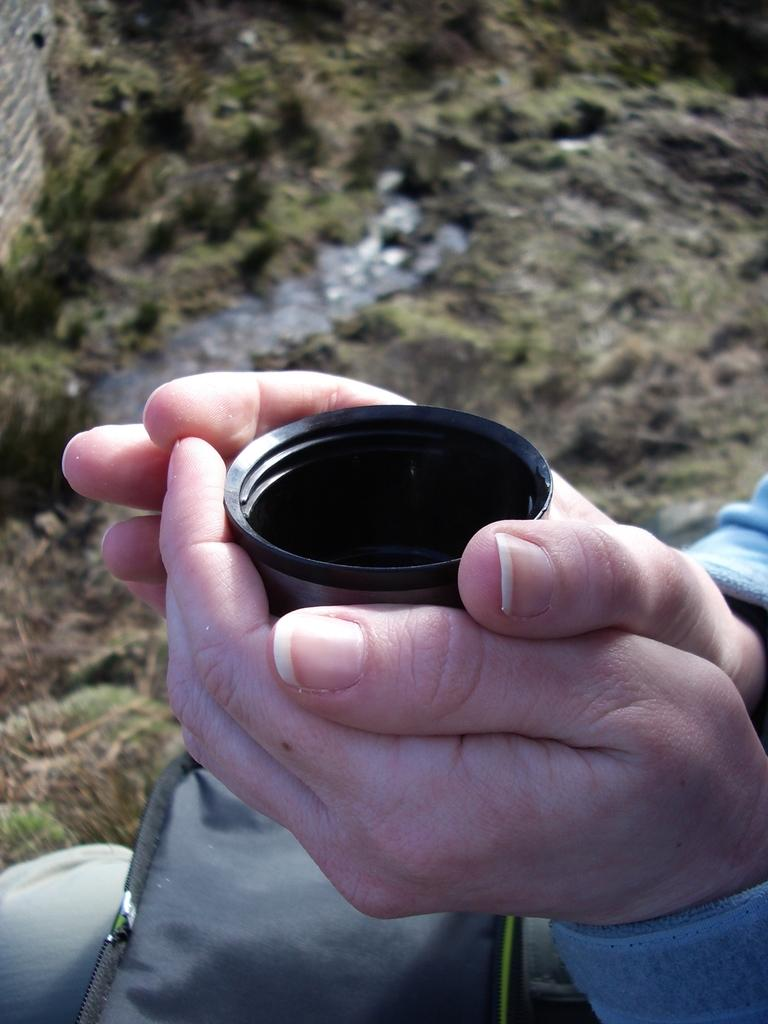What is present in the image? There is a person in the image. What is the person doing in the image? The person is holding an object. What type of degree is the person holding in the image? There is no degree present in the image; the person is holding an object, but it is not specified as a degree. 